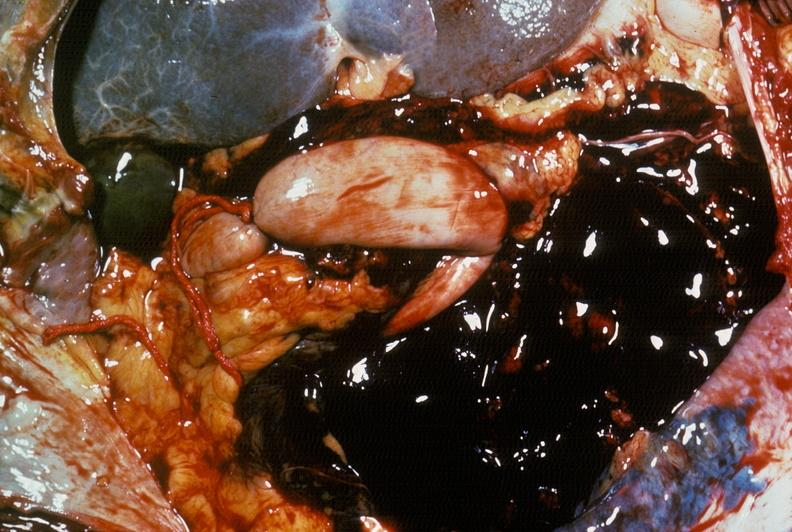what does this image show?
Answer the question using a single word or phrase. Hemorrhage secondary to ruptured aneurysm 